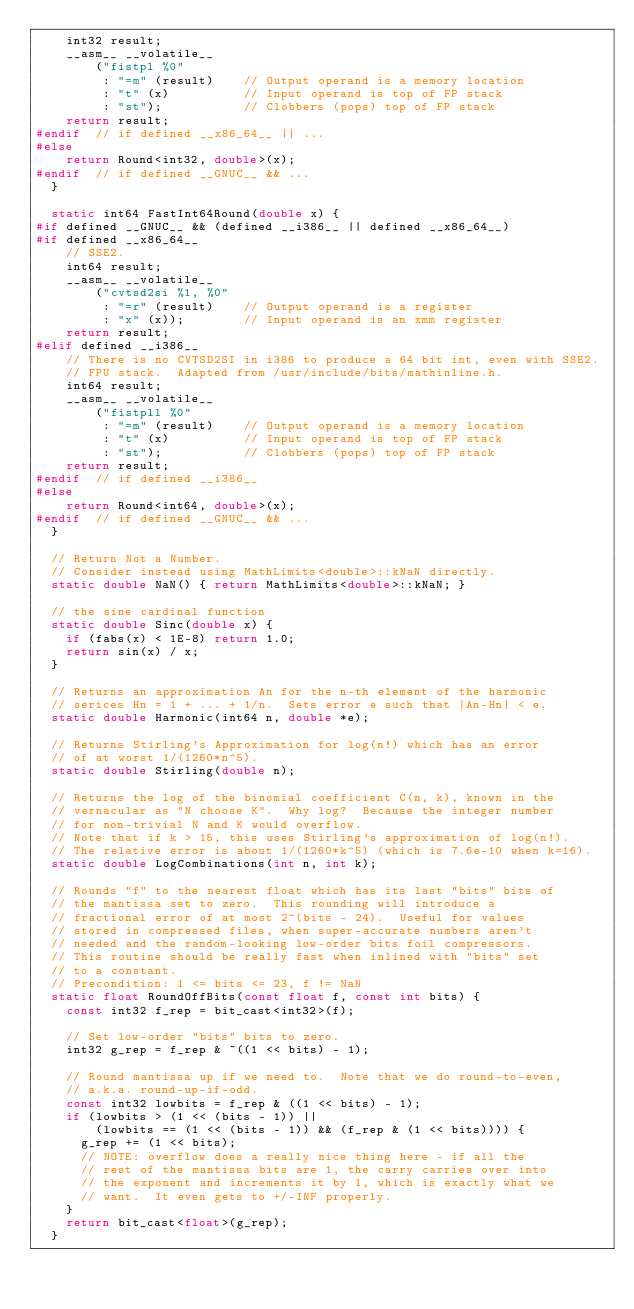Convert code to text. <code><loc_0><loc_0><loc_500><loc_500><_C_>    int32 result;
    __asm__ __volatile__
        ("fistpl %0"
         : "=m" (result)    // Output operand is a memory location
         : "t" (x)          // Input operand is top of FP stack
         : "st");           // Clobbers (pops) top of FP stack
    return result;
#endif  // if defined __x86_64__ || ...
#else
    return Round<int32, double>(x);
#endif  // if defined __GNUC__ && ...
  }

  static int64 FastInt64Round(double x) {
#if defined __GNUC__ && (defined __i386__ || defined __x86_64__)
#if defined __x86_64__
    // SSE2.
    int64 result;
    __asm__ __volatile__
        ("cvtsd2si %1, %0"
         : "=r" (result)    // Output operand is a register
         : "x" (x));        // Input operand is an xmm register
    return result;
#elif defined __i386__
    // There is no CVTSD2SI in i386 to produce a 64 bit int, even with SSE2.
    // FPU stack.  Adapted from /usr/include/bits/mathinline.h.
    int64 result;
    __asm__ __volatile__
        ("fistpll %0"
         : "=m" (result)    // Output operand is a memory location
         : "t" (x)          // Input operand is top of FP stack
         : "st");           // Clobbers (pops) top of FP stack
    return result;
#endif  // if defined __i386__
#else
    return Round<int64, double>(x);
#endif  // if defined __GNUC__ && ...
  }

  // Return Not a Number.
  // Consider instead using MathLimits<double>::kNaN directly.
  static double NaN() { return MathLimits<double>::kNaN; }

  // the sine cardinal function
  static double Sinc(double x) {
    if (fabs(x) < 1E-8) return 1.0;
    return sin(x) / x;
  }

  // Returns an approximation An for the n-th element of the harmonic
  // serices Hn = 1 + ... + 1/n.  Sets error e such that |An-Hn| < e.
  static double Harmonic(int64 n, double *e);

  // Returns Stirling's Approximation for log(n!) which has an error
  // of at worst 1/(1260*n^5).
  static double Stirling(double n);

  // Returns the log of the binomial coefficient C(n, k), known in the
  // vernacular as "N choose K".  Why log?  Because the integer number
  // for non-trivial N and K would overflow.
  // Note that if k > 15, this uses Stirling's approximation of log(n!).
  // The relative error is about 1/(1260*k^5) (which is 7.6e-10 when k=16).
  static double LogCombinations(int n, int k);

  // Rounds "f" to the nearest float which has its last "bits" bits of
  // the mantissa set to zero.  This rounding will introduce a
  // fractional error of at most 2^(bits - 24).  Useful for values
  // stored in compressed files, when super-accurate numbers aren't
  // needed and the random-looking low-order bits foil compressors.
  // This routine should be really fast when inlined with "bits" set
  // to a constant.
  // Precondition: 1 <= bits <= 23, f != NaN
  static float RoundOffBits(const float f, const int bits) {
    const int32 f_rep = bit_cast<int32>(f);

    // Set low-order "bits" bits to zero.
    int32 g_rep = f_rep & ~((1 << bits) - 1);

    // Round mantissa up if we need to.  Note that we do round-to-even,
    // a.k.a. round-up-if-odd.
    const int32 lowbits = f_rep & ((1 << bits) - 1);
    if (lowbits > (1 << (bits - 1)) ||
        (lowbits == (1 << (bits - 1)) && (f_rep & (1 << bits)))) {
      g_rep += (1 << bits);
      // NOTE: overflow does a really nice thing here - if all the
      // rest of the mantissa bits are 1, the carry carries over into
      // the exponent and increments it by 1, which is exactly what we
      // want.  It even gets to +/-INF properly.
    }
    return bit_cast<float>(g_rep);
  }</code> 